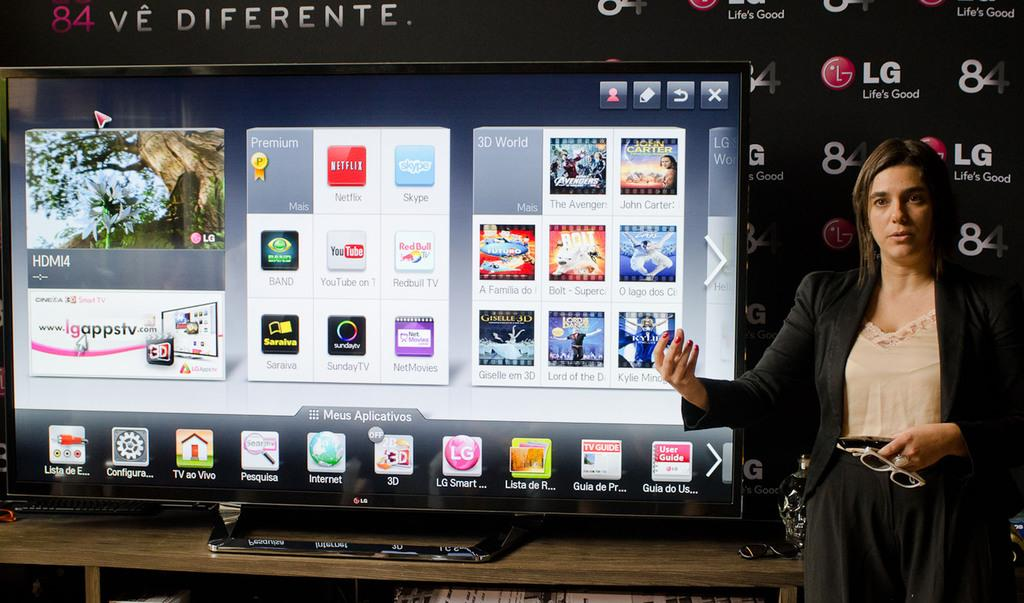<image>
Present a compact description of the photo's key features. A woman stands by a display sponsored by LG. 